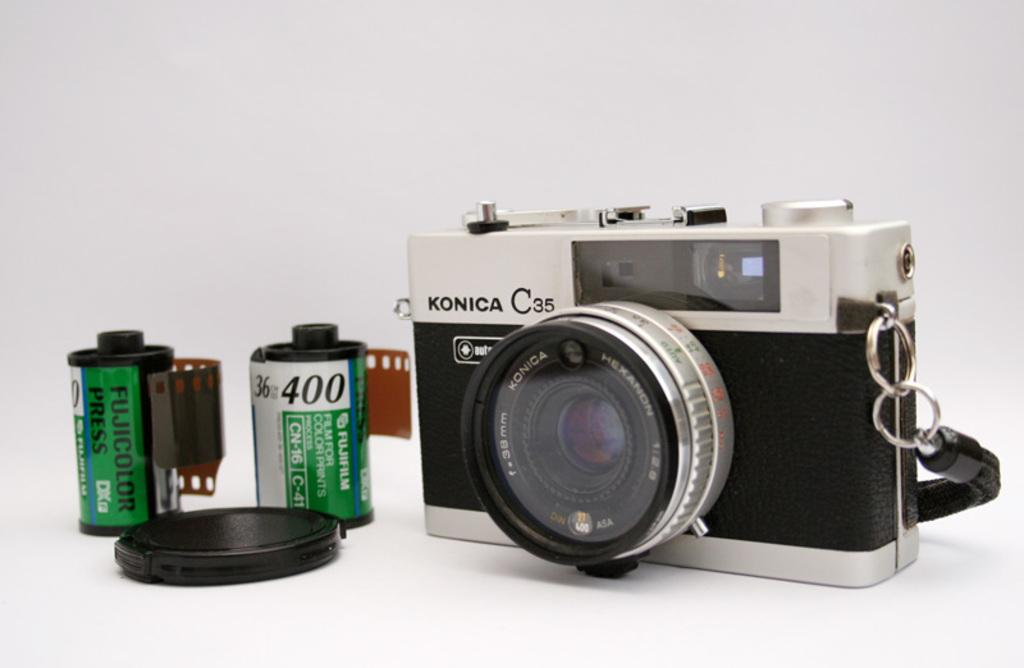What type of equipment is present in the image? There is one camera and two Fujicolor press in the image. What is associated with the camera in the image? There is one camera lens in the image. What route does the substance take to reach the camera in the image? There is no substance present in the image, and therefore no route can be determined. 